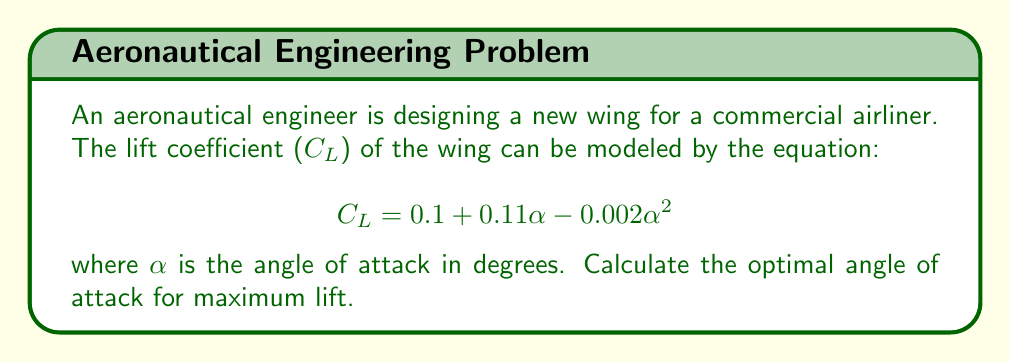Can you solve this math problem? To find the optimal angle of attack for maximum lift, we need to find the maximum value of the lift coefficient $C_L$. This occurs when the derivative of $C_L$ with respect to $\alpha$ is zero.

Step 1: Calculate the derivative of $C_L$ with respect to $\alpha$:
$$\frac{dC_L}{d\alpha} = 0.11 - 0.004\alpha$$

Step 2: Set the derivative equal to zero and solve for $\alpha$:
$$0.11 - 0.004\alpha = 0$$
$$0.004\alpha = 0.11$$
$$\alpha = \frac{0.11}{0.004} = 27.5$$

Step 3: Verify that this is a maximum by checking the second derivative:
$$\frac{d^2C_L}{d\alpha^2} = -0.004$$
Since the second derivative is negative, this confirms that $\alpha = 27.5°$ gives a maximum.

Step 4: Calculate the maximum lift coefficient:
$$C_{L_{max}} = 0.1 + 0.11(27.5) - 0.002(27.5)^2$$
$$C_{L_{max}} = 0.1 + 3.025 - 1.5125 = 1.6125$$

[asy]
import graph;
size(200,150);
real f(real x) {return 0.1 + 0.11*x - 0.002*x^2;}
xaxis("Angle of Attack (α)", Arrow);
yaxis("Lift Coefficient (C_L)", Arrow);
draw(graph(f,0,40));
dot((27.5,f(27.5)),red);
label("Maximum",((27.5,f(27.5))),N);
[/asy]
Answer: 27.5° 